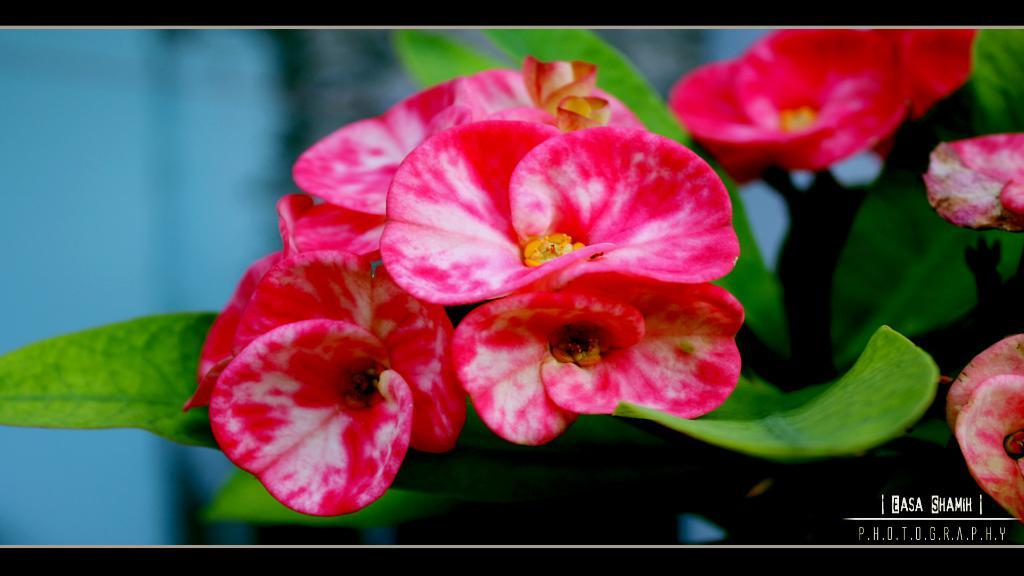What is present in the picture? There is a plant in the picture. What features does the plant have? The plant has leaves and flowers. What color are the flowers? The flowers are dark pink in color. Are there any additional details about the flowers? Yes, the flowers have white shades on them. How does the plant change its size in the image? The plant does not change its size in the image; it remains the same throughout the picture. 